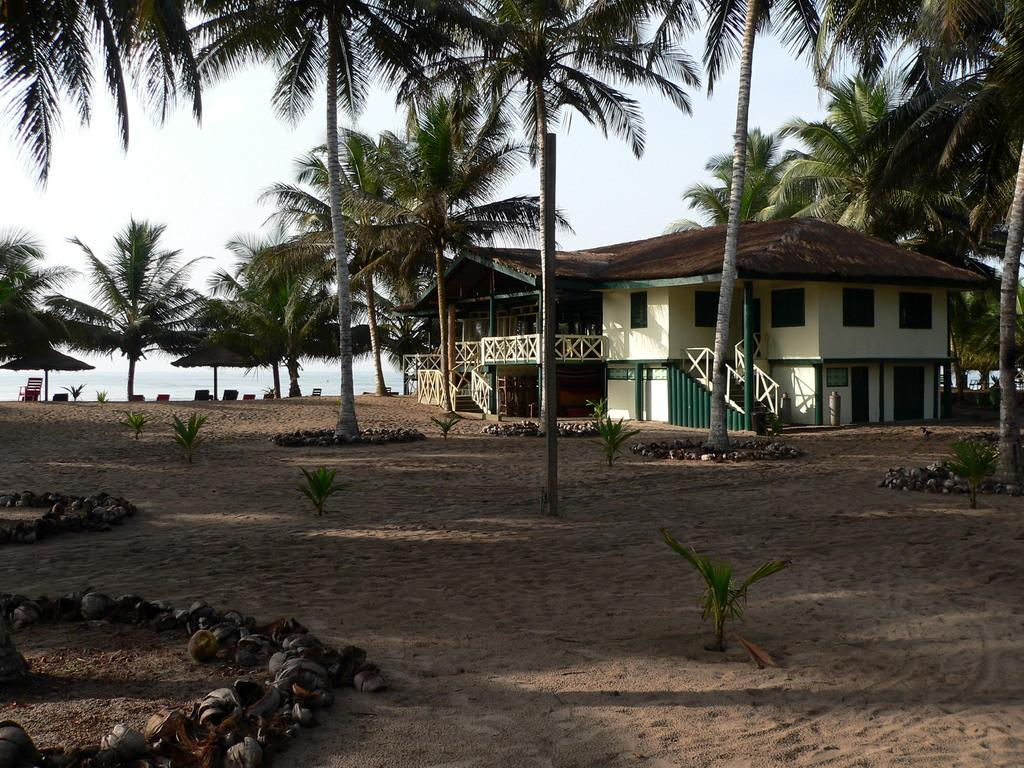What type of vegetation can be seen in the image? There are trees in the image. What type of structure is present in the image? There is a house in the image. What natural element is visible in the image? There is water visible in the image. What type of terrain is present in the image? There is mud in the image. What is visible above the landscape in the image? The sky is visible in the image. How many eyes can be seen on the trees in the image? Trees do not have eyes, so there are no eyes visible on the trees in the image. What type of tail is visible on the water in the image? There are no tails present in the image, as the water is a natural element and not an animal. 